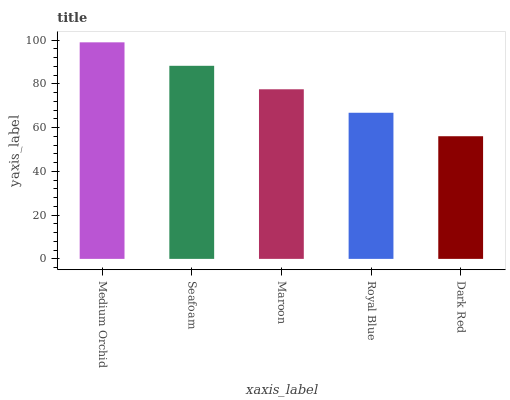Is Dark Red the minimum?
Answer yes or no. Yes. Is Medium Orchid the maximum?
Answer yes or no. Yes. Is Seafoam the minimum?
Answer yes or no. No. Is Seafoam the maximum?
Answer yes or no. No. Is Medium Orchid greater than Seafoam?
Answer yes or no. Yes. Is Seafoam less than Medium Orchid?
Answer yes or no. Yes. Is Seafoam greater than Medium Orchid?
Answer yes or no. No. Is Medium Orchid less than Seafoam?
Answer yes or no. No. Is Maroon the high median?
Answer yes or no. Yes. Is Maroon the low median?
Answer yes or no. Yes. Is Royal Blue the high median?
Answer yes or no. No. Is Dark Red the low median?
Answer yes or no. No. 